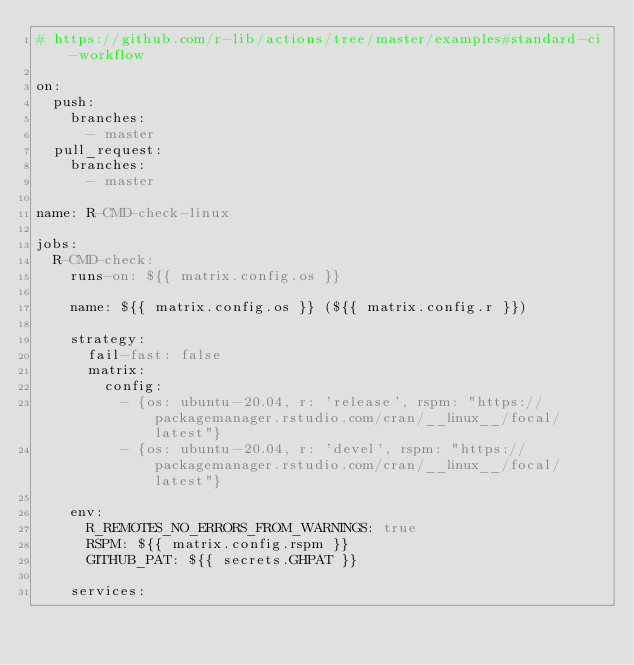<code> <loc_0><loc_0><loc_500><loc_500><_YAML_># https://github.com/r-lib/actions/tree/master/examples#standard-ci-workflow

on:
  push:
    branches:
      - master
  pull_request:
    branches:
      - master

name: R-CMD-check-linux

jobs:
  R-CMD-check:
    runs-on: ${{ matrix.config.os }}

    name: ${{ matrix.config.os }} (${{ matrix.config.r }})

    strategy:
      fail-fast: false
      matrix:
        config:
          - {os: ubuntu-20.04, r: 'release', rspm: "https://packagemanager.rstudio.com/cran/__linux__/focal/latest"}
          - {os: ubuntu-20.04, r: 'devel', rspm: "https://packagemanager.rstudio.com/cran/__linux__/focal/latest"}

    env:
      R_REMOTES_NO_ERRORS_FROM_WARNINGS: true
      RSPM: ${{ matrix.config.rspm }}
      GITHUB_PAT: ${{ secrets.GHPAT }}

    services:</code> 